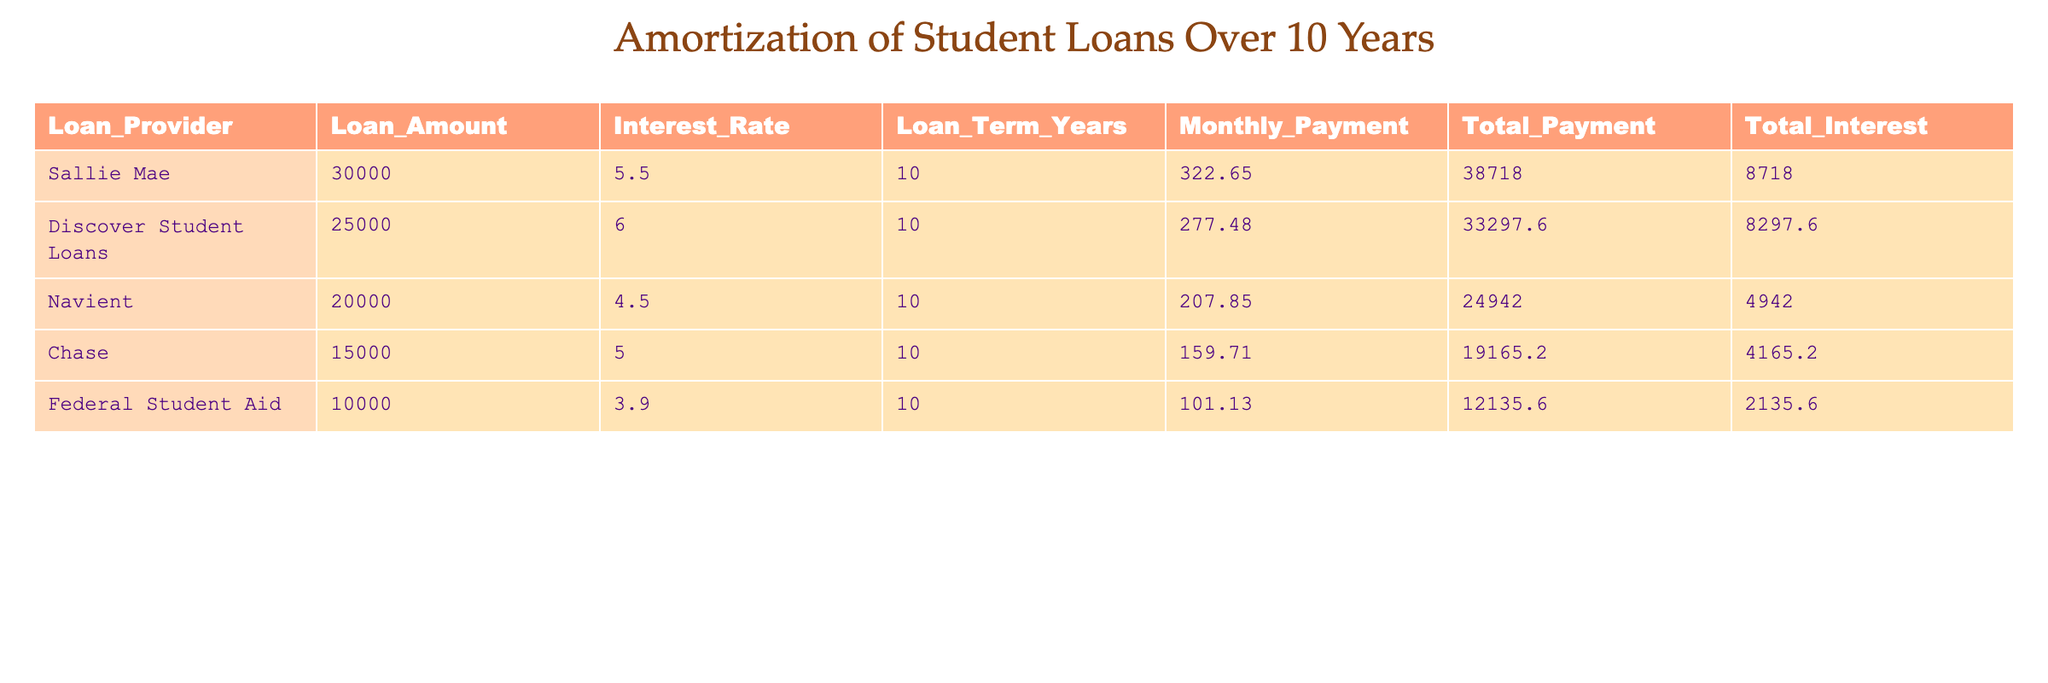What is the total payment for the loan from Sallie Mae? The total payment for the loan from Sallie Mae is directly listed in the table under the Total Payment column for that loan provider. The value is 38718.00.
Answer: 38718.00 Which loan has the highest interest rate? By comparing the Interest Rate column for each loan provider, Discover Student Loans has the highest interest rate at 6.0%.
Answer: Discover Student Loans What is the total amount of interest paid for the loan from Federal Student Aid? The total interest paid is presented in the Total Interest column, and for Federal Student Aid, this value is 2135.60.
Answer: 2135.60 How much more total payment does Sallie Mae charge compared to Chase? To find the difference, we compare the Total Payment values for Sallie Mae (38718.00) and Chase (19165.20). Subtracting Chase's total from Sallie Mae's total gives 38718.00 - 19165.20 = 19552.80.
Answer: 19552.80 Is the monthly payment for Navient greater than the monthly payment for Chase? By looking at the Monthly Payment column, Navient's monthly payment is 207.85, and Chase's is 159.71. Since 207.85 is greater than 159.71, the answer is Yes.
Answer: Yes What is the average total interest paid across all loans? To find the average, sum all the Total Interest values: (8718.00 + 8297.60 + 4942.00 + 4165.20 + 2135.60) = 18458.40. Then divide by the number of loans, which is 5: 18458.40 / 5 = 3691.68.
Answer: 3691.68 Who has the lowest loan amount, and what is it? Reviewing the Loan Amount column, Federal Student Aid has the lowest loan amount at 10000.00.
Answer: Federal Student Aid, 10000.00 If you were to take all the total payments and combine them, what would the final amount be? To find the total, sum each Total Payment value: 38718.00 + 33297.60 + 24942.00 + 19165.20 + 12135.60 = 128258.40.
Answer: 128258.40 Which loan provider has a total payment less than 30000.00? Looking through the Total Payment column, only Chase has a total payment that is less than 30000.00, which amounts to 19165.20.
Answer: Chase 